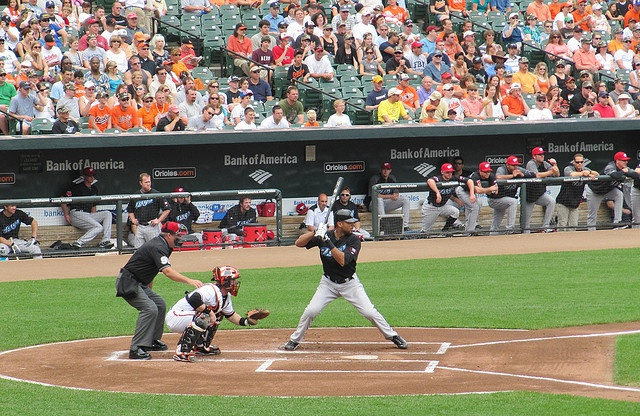Describe the objects in this image and their specific colors. I can see people in black, lightgray, gray, and darkgray tones, chair in black, darkgray, gray, teal, and white tones, people in black, lightgray, darkgray, and gray tones, people in black, gray, darkgray, and brown tones, and people in black, white, gray, and darkgray tones in this image. 